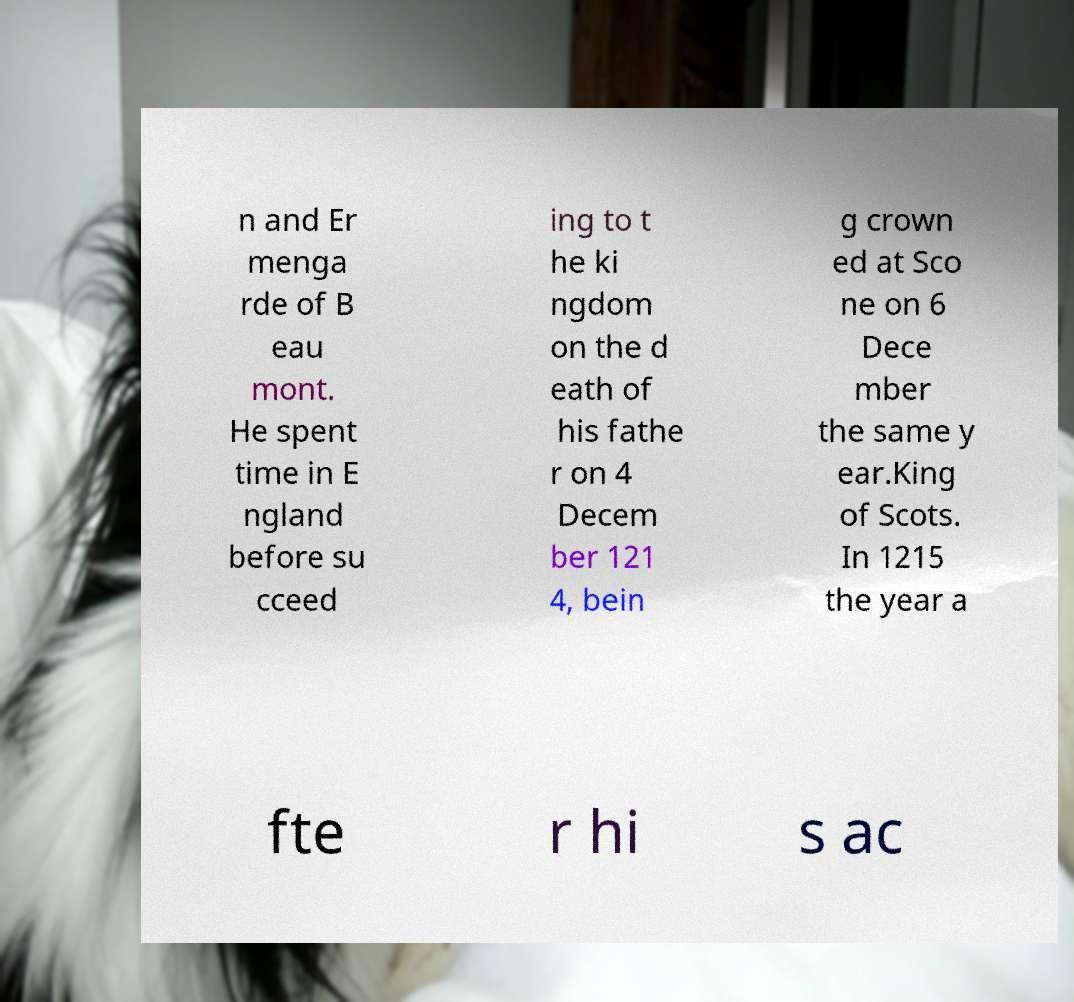Can you accurately transcribe the text from the provided image for me? n and Er menga rde of B eau mont. He spent time in E ngland before su cceed ing to t he ki ngdom on the d eath of his fathe r on 4 Decem ber 121 4, bein g crown ed at Sco ne on 6 Dece mber the same y ear.King of Scots. In 1215 the year a fte r hi s ac 